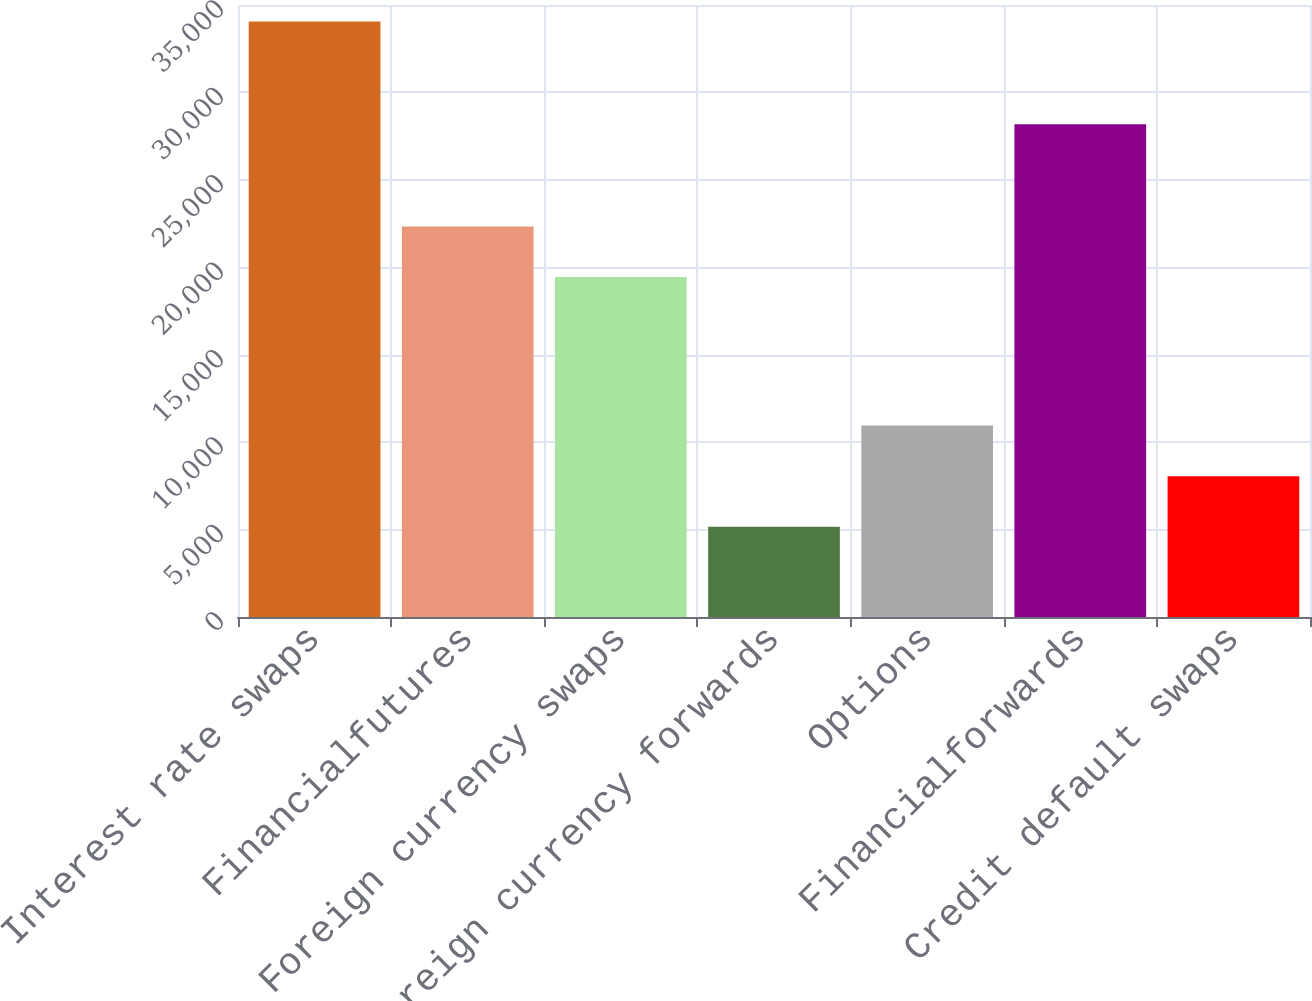Convert chart. <chart><loc_0><loc_0><loc_500><loc_500><bar_chart><fcel>Interest rate swaps<fcel>Financialfutures<fcel>Foreign currency swaps<fcel>Foreign currency forwards<fcel>Options<fcel>Financialforwards<fcel>Credit default swaps<nl><fcel>34060<fcel>22327.3<fcel>19438<fcel>5167<fcel>10945.6<fcel>28176<fcel>8056.3<nl></chart> 